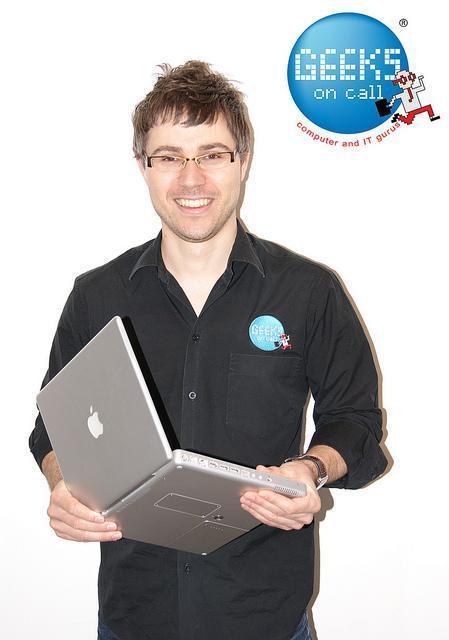How many cars aare parked next to the pile of garbage bags?
Give a very brief answer. 0. 